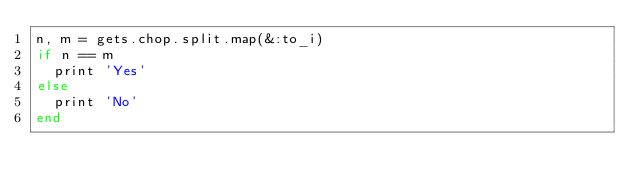<code> <loc_0><loc_0><loc_500><loc_500><_Ruby_>n, m = gets.chop.split.map(&:to_i)
if n == m
  print 'Yes'
else
  print 'No'
end</code> 